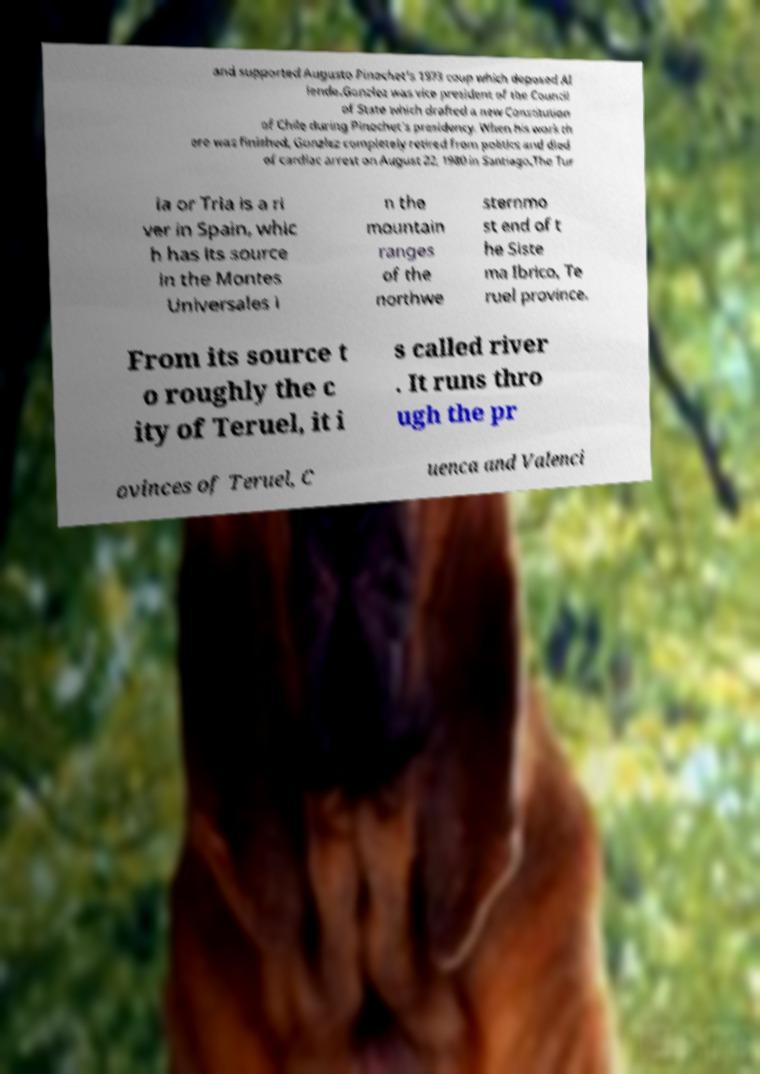Can you read and provide the text displayed in the image?This photo seems to have some interesting text. Can you extract and type it out for me? and supported Augusto Pinochet's 1973 coup which deposed Al lende.Gonzlez was vice president of the Council of State which drafted a new Constitution of Chile during Pinochet's presidency. When his work th ere was finished, Gonzlez completely retired from politics and died of cardiac arrest on August 22, 1980 in Santiago.The Tur ia or Tria is a ri ver in Spain, whic h has its source in the Montes Universales i n the mountain ranges of the northwe sternmo st end of t he Siste ma Ibrico, Te ruel province. From its source t o roughly the c ity of Teruel, it i s called river . It runs thro ugh the pr ovinces of Teruel, C uenca and Valenci 